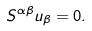Convert formula to latex. <formula><loc_0><loc_0><loc_500><loc_500>S ^ { \alpha \beta } u _ { \beta } = 0 .</formula> 